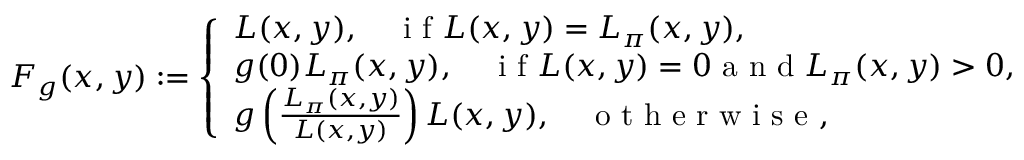Convert formula to latex. <formula><loc_0><loc_0><loc_500><loc_500>\begin{array} { r } { F _ { g } ( x , y ) \colon = \left \{ \begin{array} { l l } { L ( x , y ) , \quad i f L ( x , y ) = L _ { \pi } ( x , y ) , } \\ { g ( 0 ) L _ { \pi } ( x , y ) , \quad i f L ( x , y ) = 0 a n d L _ { \pi } ( x , y ) > 0 , } \\ { g \left ( \frac { L _ { \pi } ( x , y ) } { L ( x , y ) } \right ) L ( x , y ) , \quad o t h e r w i s e , } \end{array} } \end{array}</formula> 